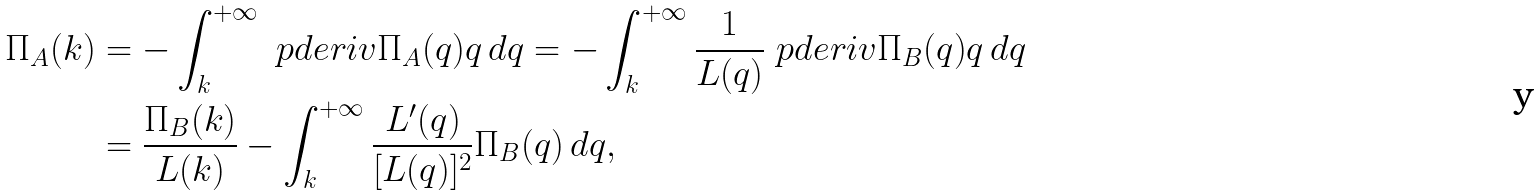Convert formula to latex. <formula><loc_0><loc_0><loc_500><loc_500>\Pi _ { A } ( k ) & = - \int _ { k } ^ { + \infty } \ p d e r i v { \Pi _ { A } ( q ) } { q } \, d q = - \int _ { k } ^ { + \infty } \frac { 1 } { L ( q ) } \ p d e r i v { \Pi _ { B } ( q ) } { q } \, d q \\ & = \frac { \Pi _ { B } ( k ) } { L ( k ) } - \int _ { k } ^ { + \infty } \frac { L ^ { \prime } ( q ) } { [ L ( q ) ] ^ { 2 } } \Pi _ { B } ( q ) \, d q ,</formula> 